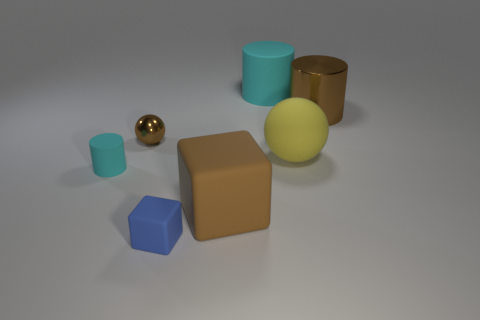Is the shape of the metal object that is to the right of the large brown block the same as  the tiny brown object?
Your answer should be very brief. No. There is a shiny object right of the big rubber object that is on the left side of the cyan thing that is on the right side of the brown block; what shape is it?
Give a very brief answer. Cylinder. There is a cyan thing left of the tiny rubber cube; what material is it?
Give a very brief answer. Rubber. The ball that is the same size as the blue cube is what color?
Your answer should be compact. Brown. How many other things are the same shape as the yellow object?
Your answer should be very brief. 1. Do the yellow matte object and the brown matte cube have the same size?
Offer a very short reply. Yes. Are there more cyan matte cylinders that are on the left side of the blue matte block than brown cylinders that are on the left side of the brown ball?
Offer a terse response. Yes. How many other objects are the same size as the brown cylinder?
Keep it short and to the point. 3. There is a tiny object that is on the left side of the tiny brown shiny object; does it have the same color as the large matte cylinder?
Provide a short and direct response. Yes. Is the number of rubber cubes that are in front of the large matte ball greater than the number of red metal spheres?
Your response must be concise. Yes. 